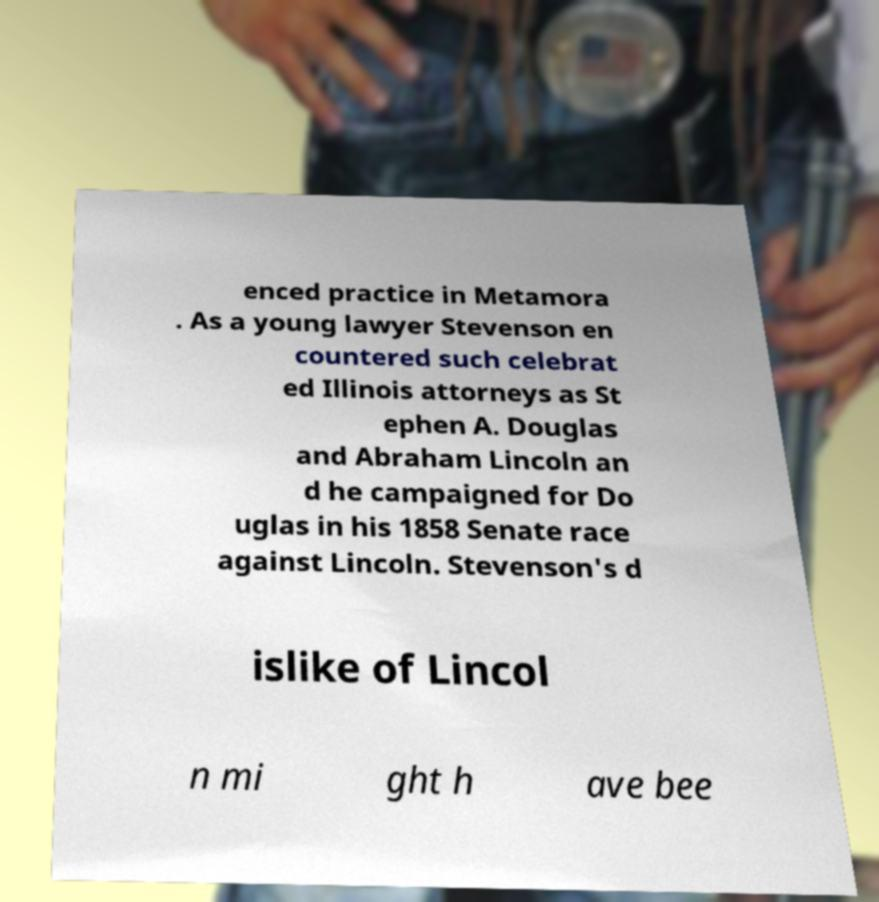Could you extract and type out the text from this image? enced practice in Metamora . As a young lawyer Stevenson en countered such celebrat ed Illinois attorneys as St ephen A. Douglas and Abraham Lincoln an d he campaigned for Do uglas in his 1858 Senate race against Lincoln. Stevenson's d islike of Lincol n mi ght h ave bee 